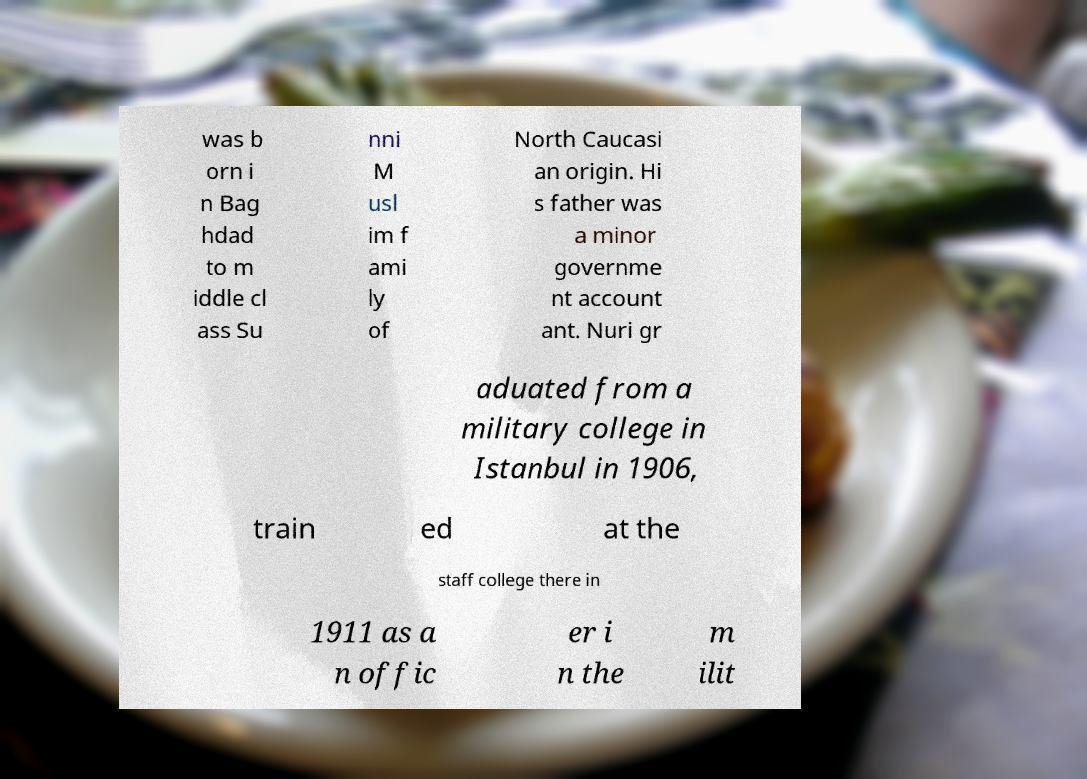What messages or text are displayed in this image? I need them in a readable, typed format. was b orn i n Bag hdad to m iddle cl ass Su nni M usl im f ami ly of North Caucasi an origin. Hi s father was a minor governme nt account ant. Nuri gr aduated from a military college in Istanbul in 1906, train ed at the staff college there in 1911 as a n offic er i n the m ilit 